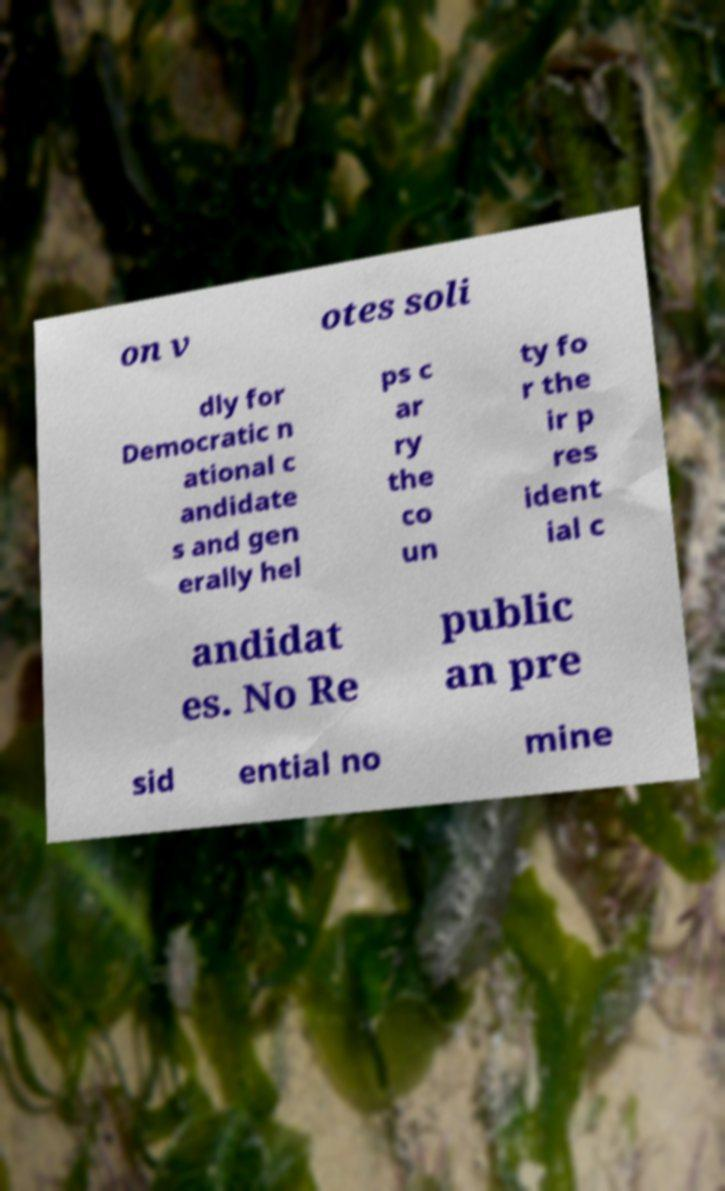Could you extract and type out the text from this image? on v otes soli dly for Democratic n ational c andidate s and gen erally hel ps c ar ry the co un ty fo r the ir p res ident ial c andidat es. No Re public an pre sid ential no mine 